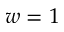Convert formula to latex. <formula><loc_0><loc_0><loc_500><loc_500>w = 1</formula> 